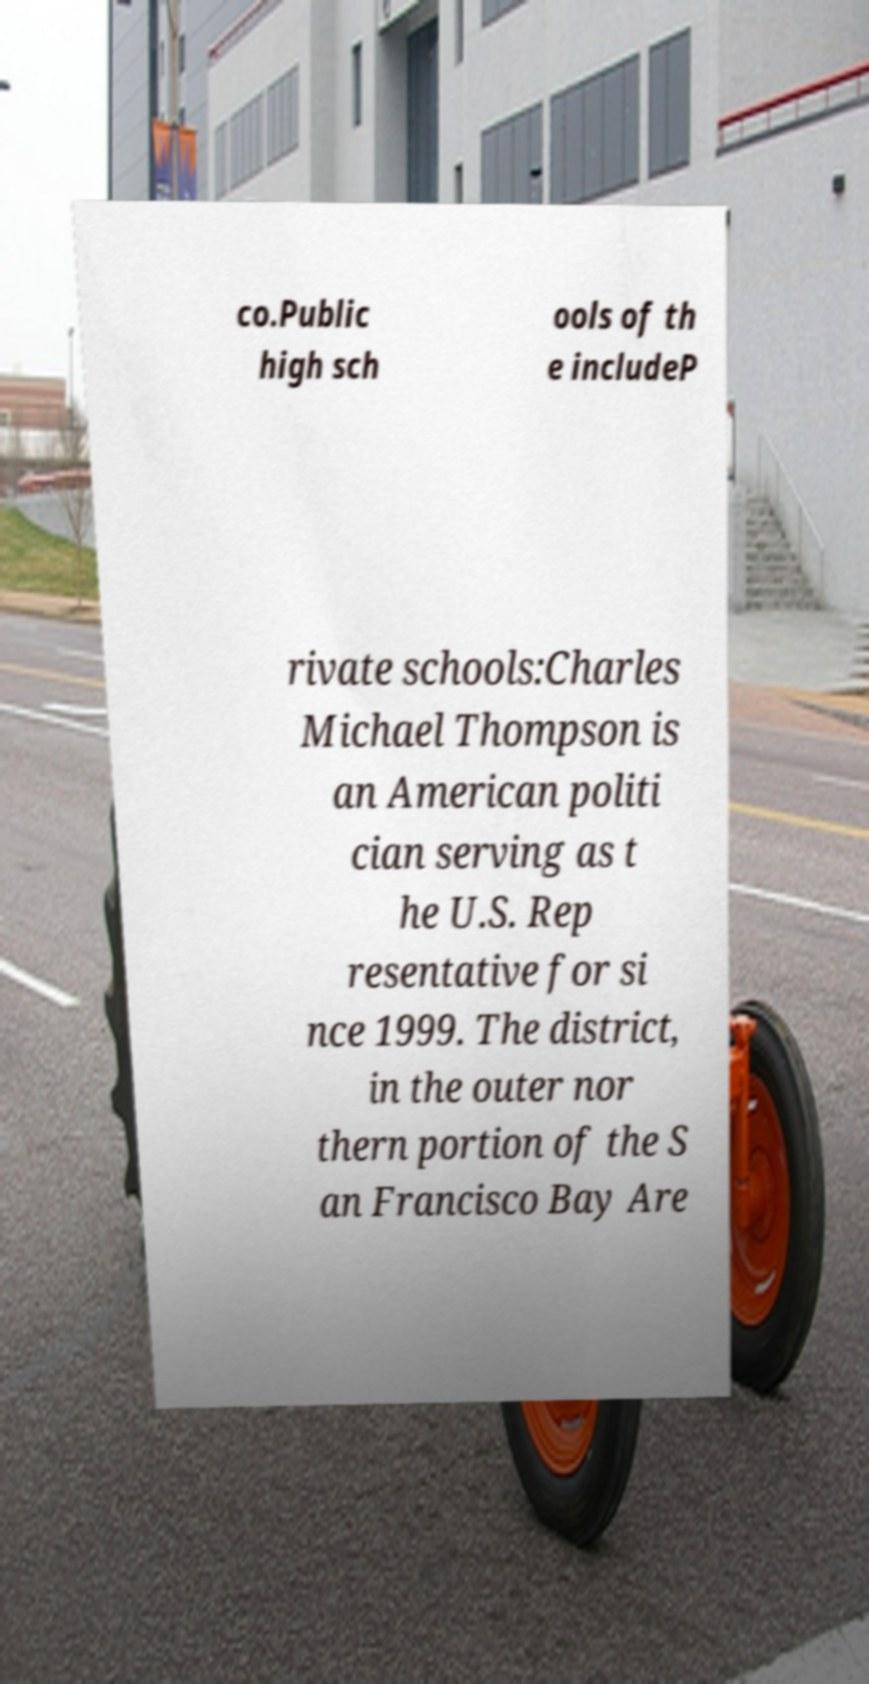Please identify and transcribe the text found in this image. co.Public high sch ools of th e includeP rivate schools:Charles Michael Thompson is an American politi cian serving as t he U.S. Rep resentative for si nce 1999. The district, in the outer nor thern portion of the S an Francisco Bay Are 